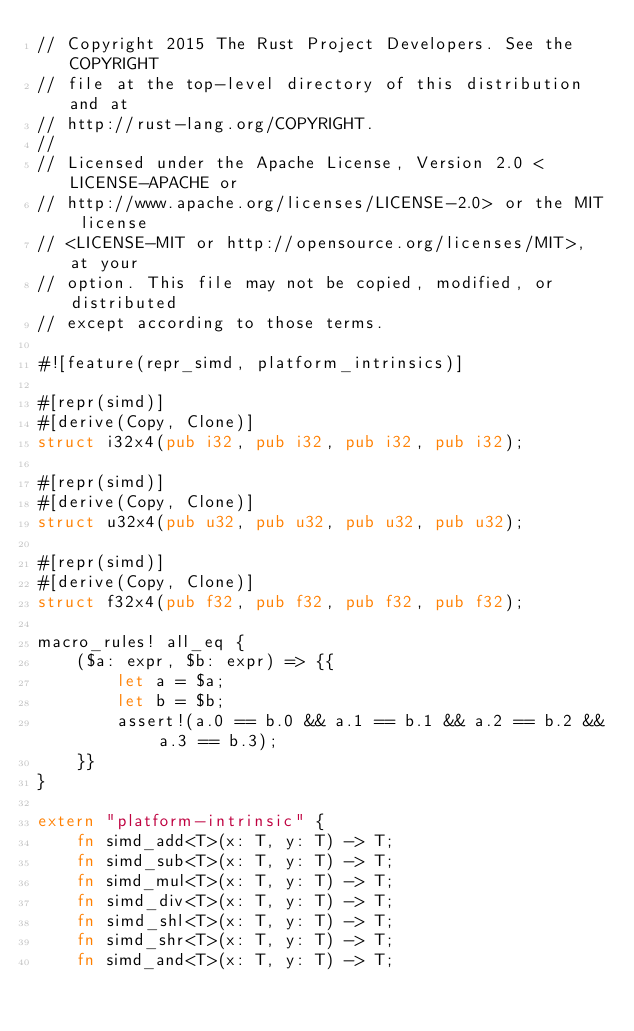<code> <loc_0><loc_0><loc_500><loc_500><_Rust_>// Copyright 2015 The Rust Project Developers. See the COPYRIGHT
// file at the top-level directory of this distribution and at
// http://rust-lang.org/COPYRIGHT.
//
// Licensed under the Apache License, Version 2.0 <LICENSE-APACHE or
// http://www.apache.org/licenses/LICENSE-2.0> or the MIT license
// <LICENSE-MIT or http://opensource.org/licenses/MIT>, at your
// option. This file may not be copied, modified, or distributed
// except according to those terms.

#![feature(repr_simd, platform_intrinsics)]

#[repr(simd)]
#[derive(Copy, Clone)]
struct i32x4(pub i32, pub i32, pub i32, pub i32);

#[repr(simd)]
#[derive(Copy, Clone)]
struct u32x4(pub u32, pub u32, pub u32, pub u32);

#[repr(simd)]
#[derive(Copy, Clone)]
struct f32x4(pub f32, pub f32, pub f32, pub f32);

macro_rules! all_eq {
    ($a: expr, $b: expr) => {{
        let a = $a;
        let b = $b;
        assert!(a.0 == b.0 && a.1 == b.1 && a.2 == b.2 && a.3 == b.3);
    }}
}

extern "platform-intrinsic" {
    fn simd_add<T>(x: T, y: T) -> T;
    fn simd_sub<T>(x: T, y: T) -> T;
    fn simd_mul<T>(x: T, y: T) -> T;
    fn simd_div<T>(x: T, y: T) -> T;
    fn simd_shl<T>(x: T, y: T) -> T;
    fn simd_shr<T>(x: T, y: T) -> T;
    fn simd_and<T>(x: T, y: T) -> T;</code> 